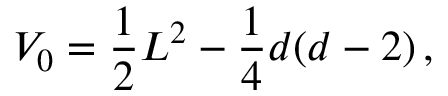Convert formula to latex. <formula><loc_0><loc_0><loc_500><loc_500>V _ { 0 } = \frac { 1 } { 2 } L ^ { 2 } - \frac { 1 } { 4 } d ( d - 2 ) \, ,</formula> 